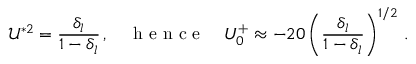Convert formula to latex. <formula><loc_0><loc_0><loc_500><loc_500>\mathcal { U } ^ { * 2 } = \frac { \delta _ { l } } { 1 - \delta _ { l } } \, , \quad h e n c e \quad U _ { 0 } ^ { + } \approx - 2 0 \left ( \frac { \delta _ { l } } { 1 - \delta _ { l } } \right ) ^ { 1 / 2 } \, .</formula> 